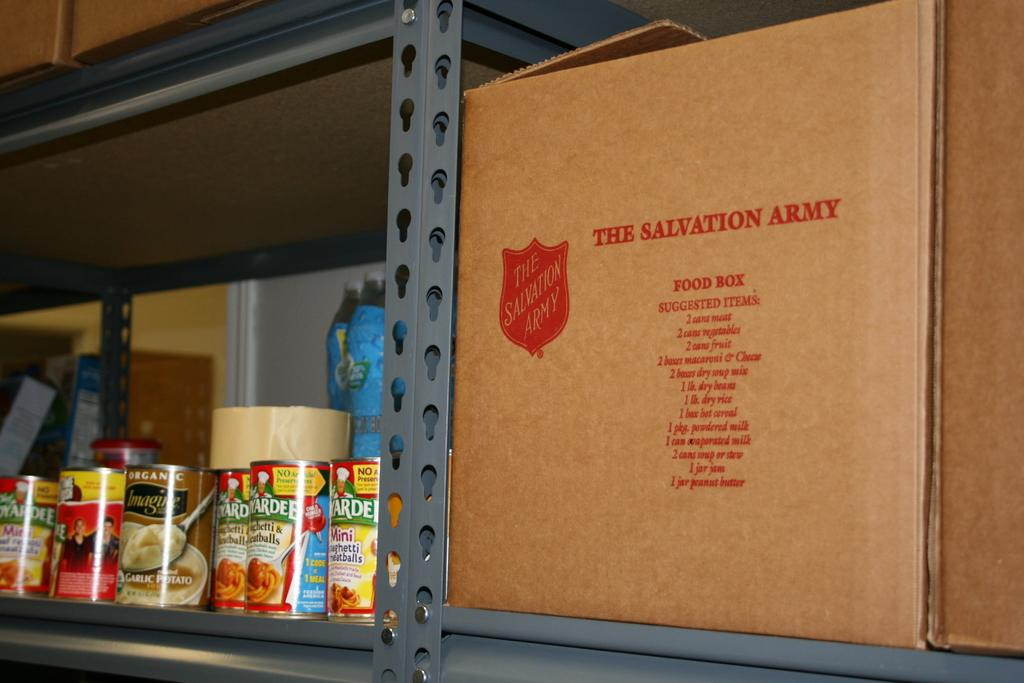Provide a one-sentence caption for the provided image. A box with a Salvation Army label Since next to some canned goods. 